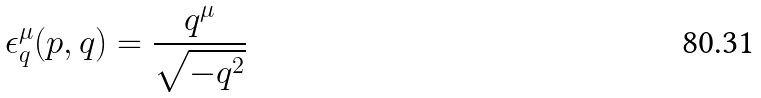Convert formula to latex. <formula><loc_0><loc_0><loc_500><loc_500>\epsilon _ { q } ^ { \mu } ( p , q ) = { \frac { q ^ { \mu } } { \sqrt { - q ^ { 2 } } } }</formula> 